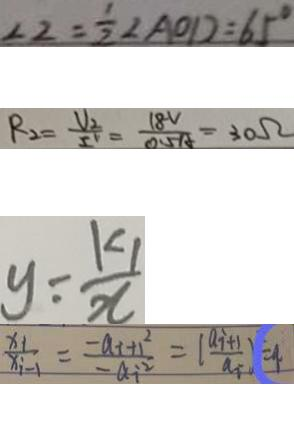<formula> <loc_0><loc_0><loc_500><loc_500>\angle 2 = \frac { 1 } { 2 } \angle A O D = 6 5 ^ { \circ } 
 R _ { 2 } = \frac { V _ { 2 } } { I ^ { v } } = \frac { 1 8 V } { 0 . 5 A } = 3 0 \Omega 
 y = \frac { k _ { 1 } } { x } 
 \frac { x _ { i } } { x _ { i - 1 } } = \frac { - a _ { i } + 1 ^ { 2 } } { - a _ { i ^ { 2 } } } = ( \frac { a _ { i + 1 } } { a _ { i } } ) = 9</formula> 